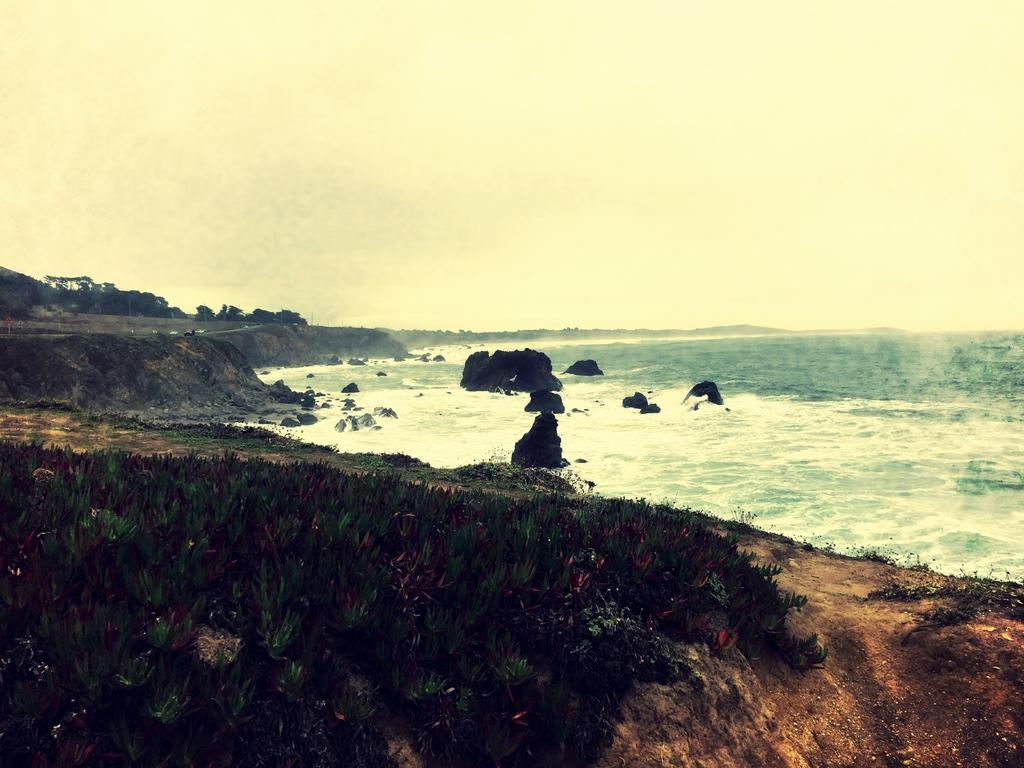Can you describe this image briefly? This is the picture of the sea and there are some rocks. In this image we can see some plants on the surface and in the background, there are some trees. 